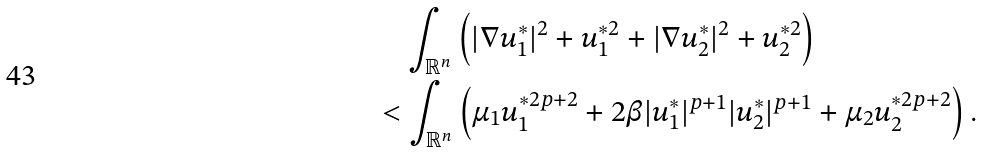<formula> <loc_0><loc_0><loc_500><loc_500>& \quad \int _ { \mathbb { R } ^ { n } } \left ( | \nabla u _ { 1 } ^ { * } | ^ { 2 } + u _ { 1 } ^ { * 2 } + | \nabla u _ { 2 } ^ { * } | ^ { 2 } + u _ { 2 } ^ { * 2 } \right ) \\ & < \int _ { \mathbb { R } ^ { n } } \left ( \mu _ { 1 } u _ { 1 } ^ { * 2 p + 2 } + 2 \beta | u _ { 1 } ^ { * } | ^ { p + 1 } | u _ { 2 } ^ { * } | ^ { p + 1 } + \mu _ { 2 } u _ { 2 } ^ { * 2 p + 2 } \right ) .</formula> 